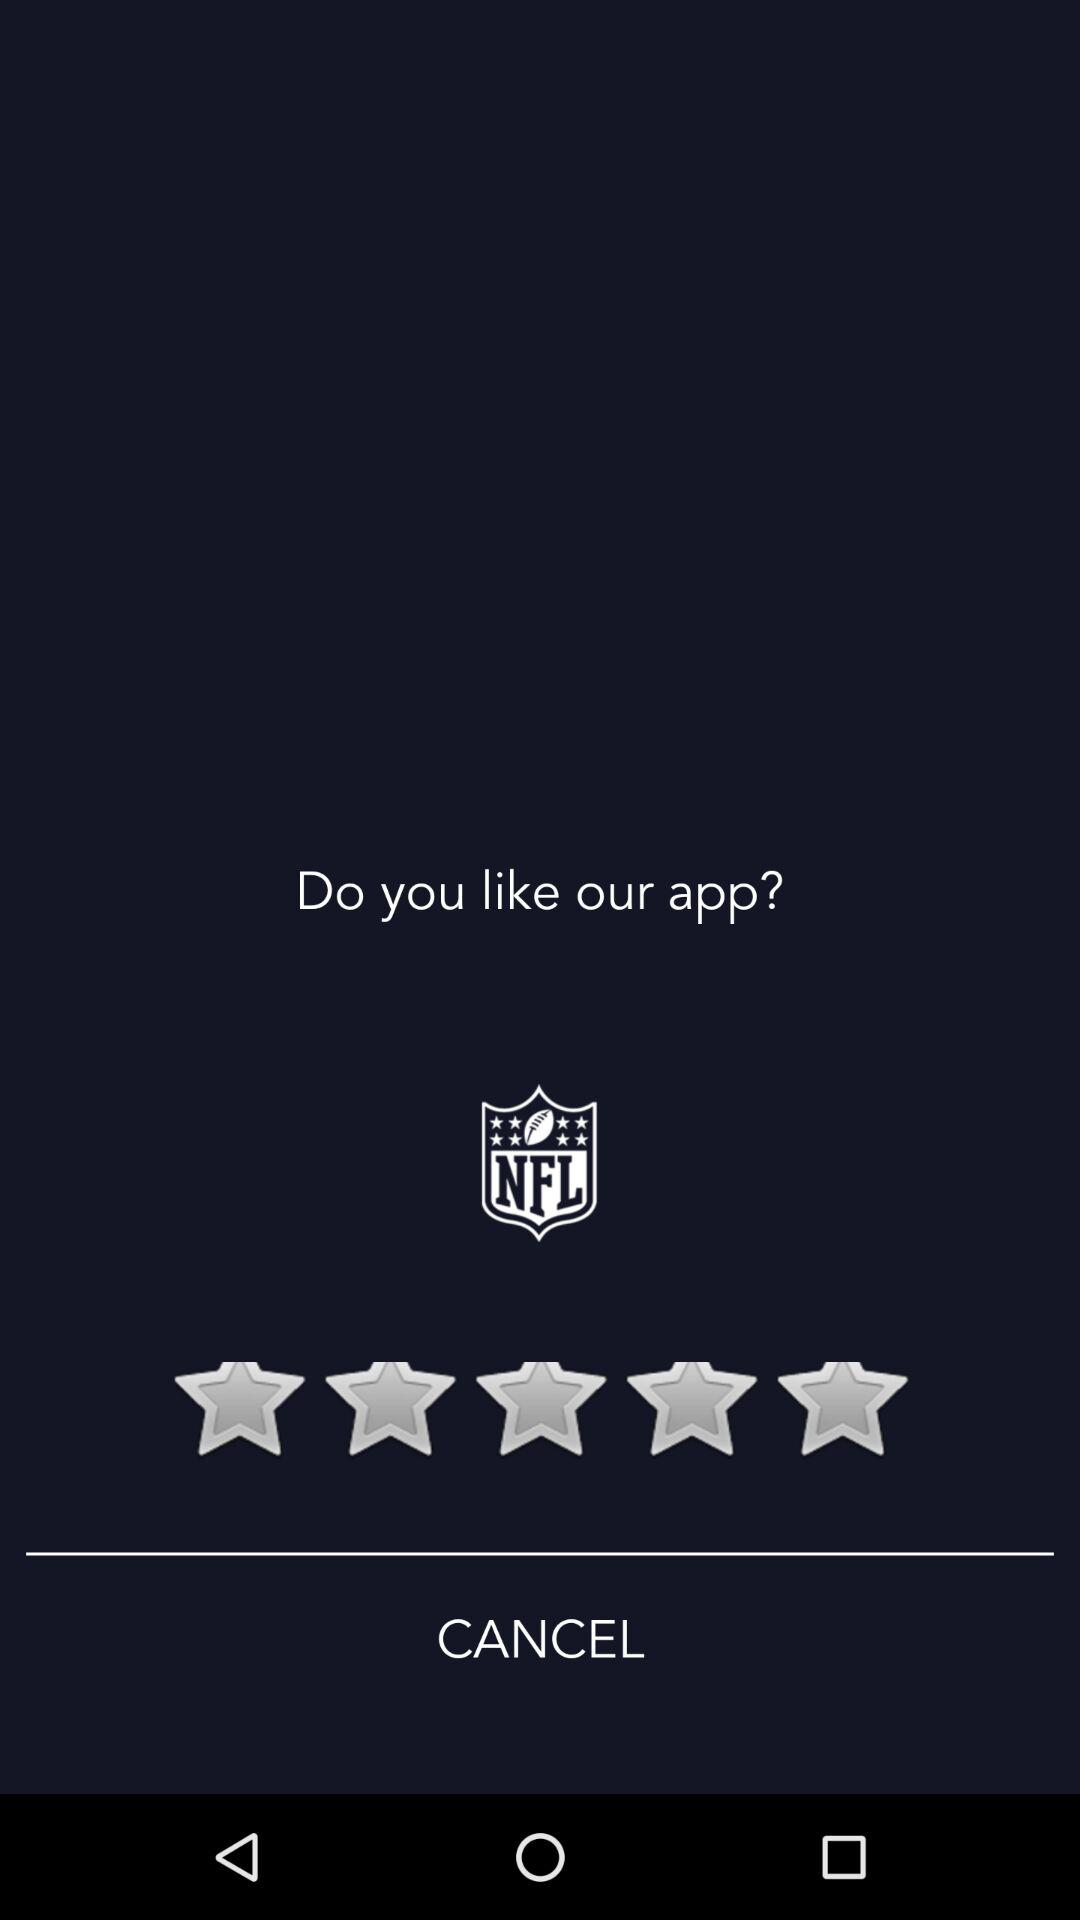What is the application name? The application name is "NFL". 